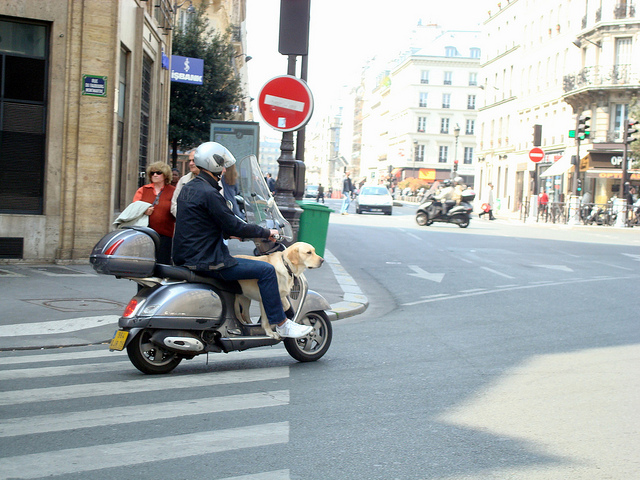Read all the text in this image. OP 